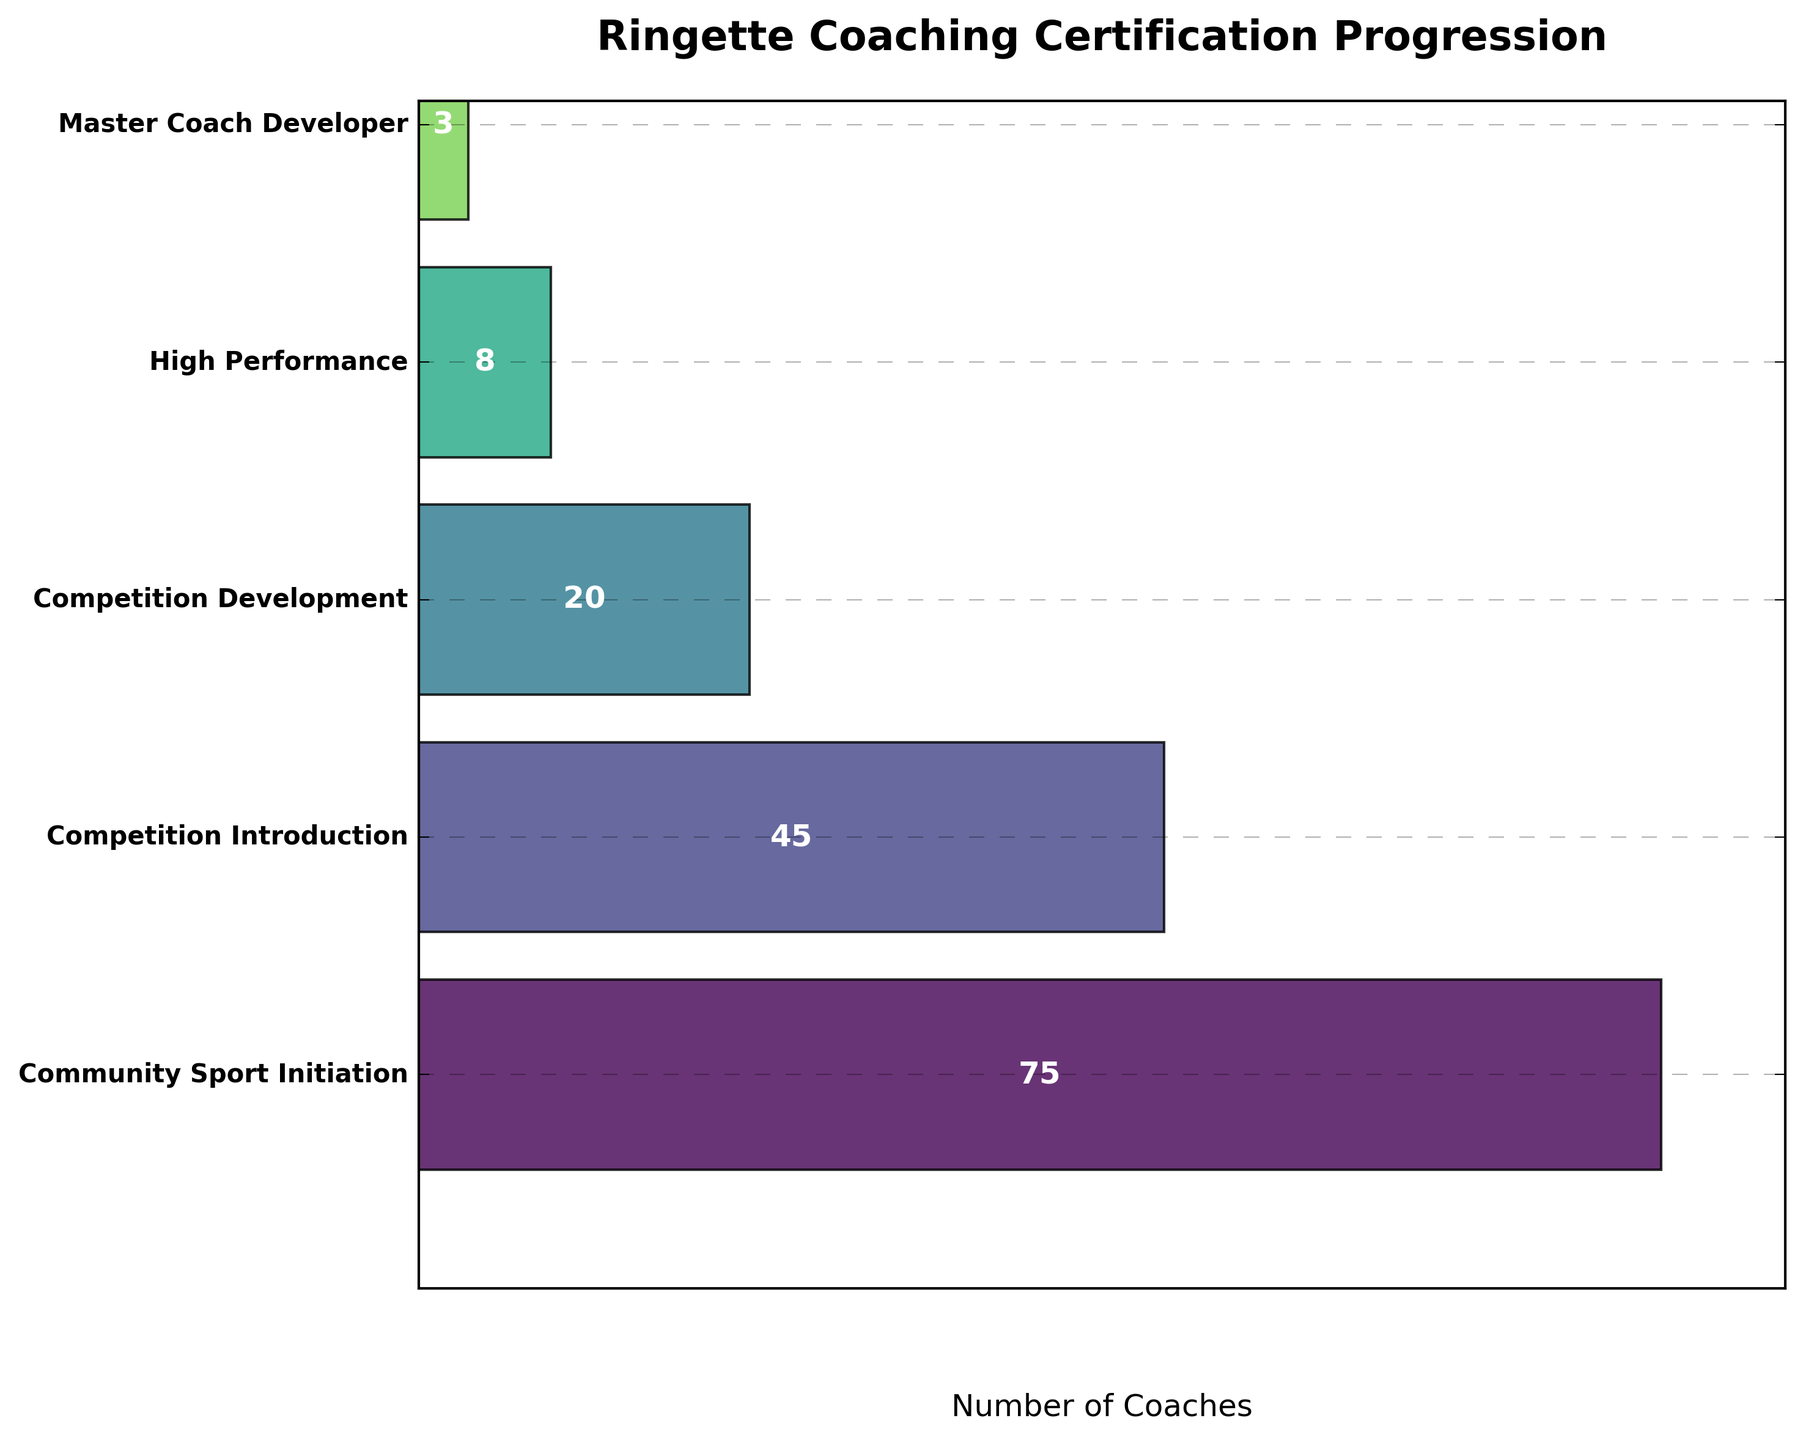What's the title of the figure? The title is displayed at the top of the funnel chart. You can see it clearly written.
Answer: Ringette Coaching Certification Progression How many stages are shown in the figure? The figure visually depicts segmented stages, and counting these segments provides the total count.
Answer: 5 How many coaches are in the Competition Introduction stage? The number of coaches is directly labeled on each segment of the funnel chart. Look for the label on the Competition Introduction stage.
Answer: 45 What is the highest number of coaches in any certification stage? Identify the segment with the largest width and read the labeled number in that segment.
Answer: 75 Comparing Community Sport Initiation and Competition Development stages, which has fewer coaches? Refer to the labeled values in the funnel segments for these two stages and compare them.
Answer: Competition Development What is the difference in the number of coaches between the Community Sport Initiation and High Performance stages? Calculate the difference by subtracting the number of coaches in the High Performance stage from the Community Sport Initiation stage. (75 - 8)
Answer: 67 How many total coaches are there in all stages combined? Sum the labeled values for all the stages: 75 + 45 + 20 + 8 + 3.
Answer: 151 Which stage has the smallest number of coaches? Inspect the funnel chart and find the segment with the smallest labeled value.
Answer: Master Coach Developer What percentage of total coaches are in the Competition Introduction stage? Calculate the percentage by dividing the number of coaches in the Competition Introduction stage by the total number of coaches, then multiply by 100. (45 / 151) * 100
Answer: 29.8% Do any stages have the same number of coaches? Comparing the labeled values across all segments can help determine if any stages have the same number of coaches.
Answer: No 